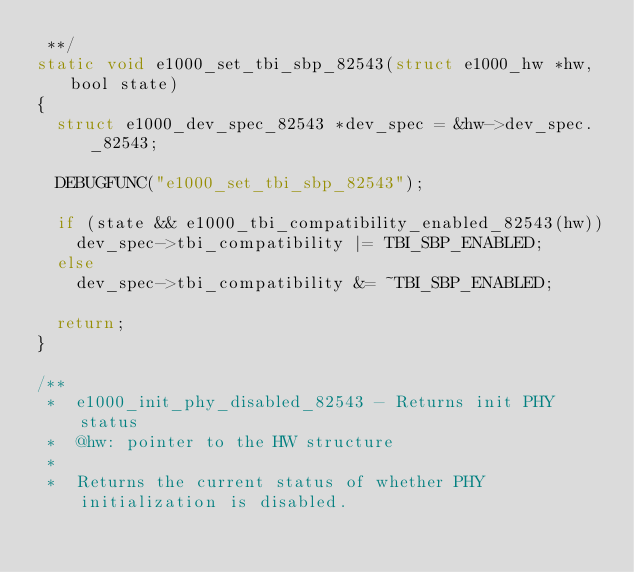Convert code to text. <code><loc_0><loc_0><loc_500><loc_500><_C_> **/
static void e1000_set_tbi_sbp_82543(struct e1000_hw *hw, bool state)
{
	struct e1000_dev_spec_82543 *dev_spec = &hw->dev_spec._82543;

	DEBUGFUNC("e1000_set_tbi_sbp_82543");

	if (state && e1000_tbi_compatibility_enabled_82543(hw))
		dev_spec->tbi_compatibility |= TBI_SBP_ENABLED;
	else
		dev_spec->tbi_compatibility &= ~TBI_SBP_ENABLED;

	return;
}

/**
 *  e1000_init_phy_disabled_82543 - Returns init PHY status
 *  @hw: pointer to the HW structure
 *
 *  Returns the current status of whether PHY initialization is disabled.</code> 